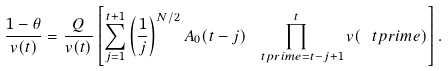Convert formula to latex. <formula><loc_0><loc_0><loc_500><loc_500>\frac { 1 - \theta } { v ( t ) } = \frac { Q } { v ( t ) } \left [ \sum _ { j = 1 } ^ { t + 1 } \left ( \frac { 1 } { j } \right ) ^ { N / 2 } A _ { 0 } ( t - j ) \prod _ { \ t p r i m e = t - j + 1 } ^ { t } v ( \ t p r i m e ) \right ] .</formula> 